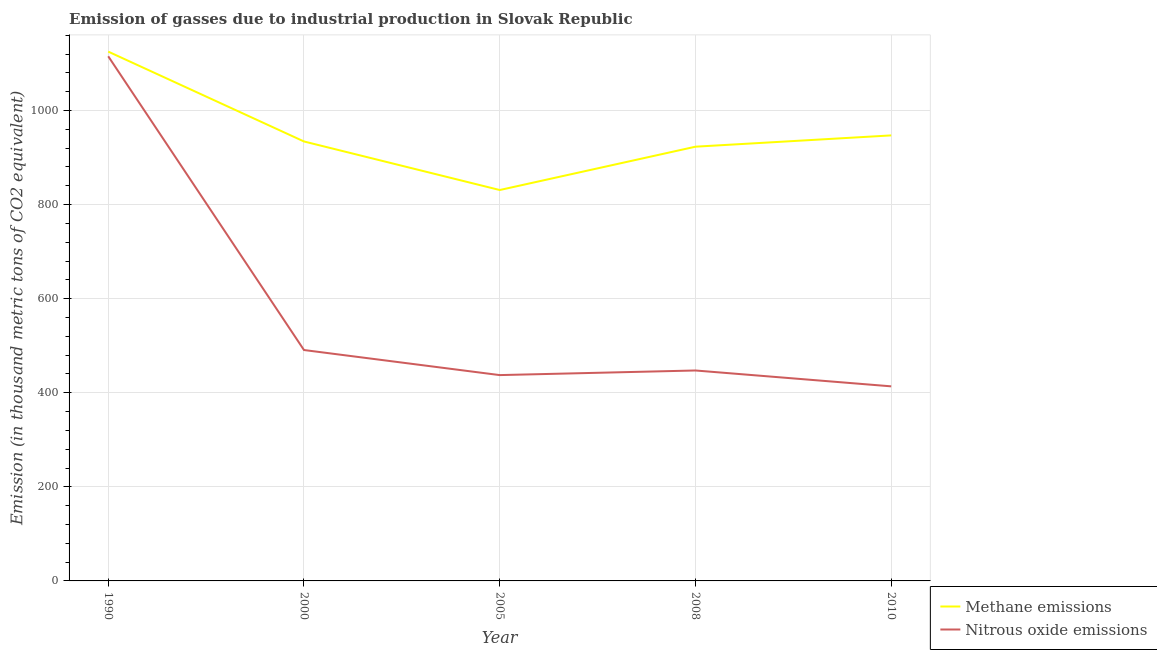What is the amount of nitrous oxide emissions in 2000?
Give a very brief answer. 490.8. Across all years, what is the maximum amount of nitrous oxide emissions?
Offer a terse response. 1115.2. Across all years, what is the minimum amount of methane emissions?
Offer a very short reply. 830.9. In which year was the amount of methane emissions minimum?
Provide a short and direct response. 2005. What is the total amount of methane emissions in the graph?
Your response must be concise. 4760.1. What is the difference between the amount of methane emissions in 2000 and that in 2010?
Offer a very short reply. -12.9. What is the difference between the amount of methane emissions in 2008 and the amount of nitrous oxide emissions in 2000?
Ensure brevity in your answer.  432.2. What is the average amount of methane emissions per year?
Offer a terse response. 952.02. In the year 1990, what is the difference between the amount of methane emissions and amount of nitrous oxide emissions?
Give a very brief answer. 9.9. What is the ratio of the amount of nitrous oxide emissions in 2000 to that in 2008?
Keep it short and to the point. 1.1. Is the amount of methane emissions in 1990 less than that in 2005?
Offer a very short reply. No. What is the difference between the highest and the second highest amount of nitrous oxide emissions?
Keep it short and to the point. 624.4. What is the difference between the highest and the lowest amount of nitrous oxide emissions?
Give a very brief answer. 701.6. In how many years, is the amount of methane emissions greater than the average amount of methane emissions taken over all years?
Offer a terse response. 1. Is the sum of the amount of nitrous oxide emissions in 2008 and 2010 greater than the maximum amount of methane emissions across all years?
Make the answer very short. No. What is the difference between two consecutive major ticks on the Y-axis?
Your answer should be very brief. 200. Are the values on the major ticks of Y-axis written in scientific E-notation?
Make the answer very short. No. Does the graph contain any zero values?
Your response must be concise. No. Does the graph contain grids?
Offer a very short reply. Yes. How many legend labels are there?
Offer a terse response. 2. What is the title of the graph?
Give a very brief answer. Emission of gasses due to industrial production in Slovak Republic. What is the label or title of the Y-axis?
Provide a short and direct response. Emission (in thousand metric tons of CO2 equivalent). What is the Emission (in thousand metric tons of CO2 equivalent) in Methane emissions in 1990?
Make the answer very short. 1125.1. What is the Emission (in thousand metric tons of CO2 equivalent) in Nitrous oxide emissions in 1990?
Your answer should be very brief. 1115.2. What is the Emission (in thousand metric tons of CO2 equivalent) in Methane emissions in 2000?
Ensure brevity in your answer.  934.1. What is the Emission (in thousand metric tons of CO2 equivalent) in Nitrous oxide emissions in 2000?
Give a very brief answer. 490.8. What is the Emission (in thousand metric tons of CO2 equivalent) of Methane emissions in 2005?
Give a very brief answer. 830.9. What is the Emission (in thousand metric tons of CO2 equivalent) in Nitrous oxide emissions in 2005?
Ensure brevity in your answer.  437.5. What is the Emission (in thousand metric tons of CO2 equivalent) of Methane emissions in 2008?
Ensure brevity in your answer.  923. What is the Emission (in thousand metric tons of CO2 equivalent) of Nitrous oxide emissions in 2008?
Give a very brief answer. 447.3. What is the Emission (in thousand metric tons of CO2 equivalent) of Methane emissions in 2010?
Offer a terse response. 947. What is the Emission (in thousand metric tons of CO2 equivalent) in Nitrous oxide emissions in 2010?
Give a very brief answer. 413.6. Across all years, what is the maximum Emission (in thousand metric tons of CO2 equivalent) in Methane emissions?
Provide a succinct answer. 1125.1. Across all years, what is the maximum Emission (in thousand metric tons of CO2 equivalent) in Nitrous oxide emissions?
Offer a very short reply. 1115.2. Across all years, what is the minimum Emission (in thousand metric tons of CO2 equivalent) in Methane emissions?
Provide a short and direct response. 830.9. Across all years, what is the minimum Emission (in thousand metric tons of CO2 equivalent) in Nitrous oxide emissions?
Give a very brief answer. 413.6. What is the total Emission (in thousand metric tons of CO2 equivalent) of Methane emissions in the graph?
Your answer should be very brief. 4760.1. What is the total Emission (in thousand metric tons of CO2 equivalent) of Nitrous oxide emissions in the graph?
Offer a terse response. 2904.4. What is the difference between the Emission (in thousand metric tons of CO2 equivalent) in Methane emissions in 1990 and that in 2000?
Ensure brevity in your answer.  191. What is the difference between the Emission (in thousand metric tons of CO2 equivalent) of Nitrous oxide emissions in 1990 and that in 2000?
Ensure brevity in your answer.  624.4. What is the difference between the Emission (in thousand metric tons of CO2 equivalent) in Methane emissions in 1990 and that in 2005?
Ensure brevity in your answer.  294.2. What is the difference between the Emission (in thousand metric tons of CO2 equivalent) of Nitrous oxide emissions in 1990 and that in 2005?
Give a very brief answer. 677.7. What is the difference between the Emission (in thousand metric tons of CO2 equivalent) in Methane emissions in 1990 and that in 2008?
Provide a short and direct response. 202.1. What is the difference between the Emission (in thousand metric tons of CO2 equivalent) in Nitrous oxide emissions in 1990 and that in 2008?
Make the answer very short. 667.9. What is the difference between the Emission (in thousand metric tons of CO2 equivalent) in Methane emissions in 1990 and that in 2010?
Give a very brief answer. 178.1. What is the difference between the Emission (in thousand metric tons of CO2 equivalent) of Nitrous oxide emissions in 1990 and that in 2010?
Give a very brief answer. 701.6. What is the difference between the Emission (in thousand metric tons of CO2 equivalent) of Methane emissions in 2000 and that in 2005?
Give a very brief answer. 103.2. What is the difference between the Emission (in thousand metric tons of CO2 equivalent) of Nitrous oxide emissions in 2000 and that in 2005?
Keep it short and to the point. 53.3. What is the difference between the Emission (in thousand metric tons of CO2 equivalent) in Nitrous oxide emissions in 2000 and that in 2008?
Offer a very short reply. 43.5. What is the difference between the Emission (in thousand metric tons of CO2 equivalent) of Methane emissions in 2000 and that in 2010?
Your answer should be compact. -12.9. What is the difference between the Emission (in thousand metric tons of CO2 equivalent) in Nitrous oxide emissions in 2000 and that in 2010?
Your response must be concise. 77.2. What is the difference between the Emission (in thousand metric tons of CO2 equivalent) in Methane emissions in 2005 and that in 2008?
Offer a very short reply. -92.1. What is the difference between the Emission (in thousand metric tons of CO2 equivalent) of Nitrous oxide emissions in 2005 and that in 2008?
Your answer should be very brief. -9.8. What is the difference between the Emission (in thousand metric tons of CO2 equivalent) of Methane emissions in 2005 and that in 2010?
Make the answer very short. -116.1. What is the difference between the Emission (in thousand metric tons of CO2 equivalent) of Nitrous oxide emissions in 2005 and that in 2010?
Ensure brevity in your answer.  23.9. What is the difference between the Emission (in thousand metric tons of CO2 equivalent) in Nitrous oxide emissions in 2008 and that in 2010?
Offer a very short reply. 33.7. What is the difference between the Emission (in thousand metric tons of CO2 equivalent) of Methane emissions in 1990 and the Emission (in thousand metric tons of CO2 equivalent) of Nitrous oxide emissions in 2000?
Provide a succinct answer. 634.3. What is the difference between the Emission (in thousand metric tons of CO2 equivalent) of Methane emissions in 1990 and the Emission (in thousand metric tons of CO2 equivalent) of Nitrous oxide emissions in 2005?
Your answer should be compact. 687.6. What is the difference between the Emission (in thousand metric tons of CO2 equivalent) of Methane emissions in 1990 and the Emission (in thousand metric tons of CO2 equivalent) of Nitrous oxide emissions in 2008?
Your answer should be compact. 677.8. What is the difference between the Emission (in thousand metric tons of CO2 equivalent) in Methane emissions in 1990 and the Emission (in thousand metric tons of CO2 equivalent) in Nitrous oxide emissions in 2010?
Provide a succinct answer. 711.5. What is the difference between the Emission (in thousand metric tons of CO2 equivalent) of Methane emissions in 2000 and the Emission (in thousand metric tons of CO2 equivalent) of Nitrous oxide emissions in 2005?
Provide a short and direct response. 496.6. What is the difference between the Emission (in thousand metric tons of CO2 equivalent) in Methane emissions in 2000 and the Emission (in thousand metric tons of CO2 equivalent) in Nitrous oxide emissions in 2008?
Offer a terse response. 486.8. What is the difference between the Emission (in thousand metric tons of CO2 equivalent) in Methane emissions in 2000 and the Emission (in thousand metric tons of CO2 equivalent) in Nitrous oxide emissions in 2010?
Offer a very short reply. 520.5. What is the difference between the Emission (in thousand metric tons of CO2 equivalent) of Methane emissions in 2005 and the Emission (in thousand metric tons of CO2 equivalent) of Nitrous oxide emissions in 2008?
Provide a succinct answer. 383.6. What is the difference between the Emission (in thousand metric tons of CO2 equivalent) of Methane emissions in 2005 and the Emission (in thousand metric tons of CO2 equivalent) of Nitrous oxide emissions in 2010?
Your answer should be compact. 417.3. What is the difference between the Emission (in thousand metric tons of CO2 equivalent) of Methane emissions in 2008 and the Emission (in thousand metric tons of CO2 equivalent) of Nitrous oxide emissions in 2010?
Your response must be concise. 509.4. What is the average Emission (in thousand metric tons of CO2 equivalent) of Methane emissions per year?
Make the answer very short. 952.02. What is the average Emission (in thousand metric tons of CO2 equivalent) of Nitrous oxide emissions per year?
Give a very brief answer. 580.88. In the year 2000, what is the difference between the Emission (in thousand metric tons of CO2 equivalent) of Methane emissions and Emission (in thousand metric tons of CO2 equivalent) of Nitrous oxide emissions?
Your answer should be compact. 443.3. In the year 2005, what is the difference between the Emission (in thousand metric tons of CO2 equivalent) in Methane emissions and Emission (in thousand metric tons of CO2 equivalent) in Nitrous oxide emissions?
Provide a short and direct response. 393.4. In the year 2008, what is the difference between the Emission (in thousand metric tons of CO2 equivalent) of Methane emissions and Emission (in thousand metric tons of CO2 equivalent) of Nitrous oxide emissions?
Your answer should be very brief. 475.7. In the year 2010, what is the difference between the Emission (in thousand metric tons of CO2 equivalent) of Methane emissions and Emission (in thousand metric tons of CO2 equivalent) of Nitrous oxide emissions?
Keep it short and to the point. 533.4. What is the ratio of the Emission (in thousand metric tons of CO2 equivalent) in Methane emissions in 1990 to that in 2000?
Your response must be concise. 1.2. What is the ratio of the Emission (in thousand metric tons of CO2 equivalent) of Nitrous oxide emissions in 1990 to that in 2000?
Offer a very short reply. 2.27. What is the ratio of the Emission (in thousand metric tons of CO2 equivalent) in Methane emissions in 1990 to that in 2005?
Provide a succinct answer. 1.35. What is the ratio of the Emission (in thousand metric tons of CO2 equivalent) in Nitrous oxide emissions in 1990 to that in 2005?
Provide a succinct answer. 2.55. What is the ratio of the Emission (in thousand metric tons of CO2 equivalent) in Methane emissions in 1990 to that in 2008?
Offer a very short reply. 1.22. What is the ratio of the Emission (in thousand metric tons of CO2 equivalent) in Nitrous oxide emissions in 1990 to that in 2008?
Provide a short and direct response. 2.49. What is the ratio of the Emission (in thousand metric tons of CO2 equivalent) of Methane emissions in 1990 to that in 2010?
Provide a succinct answer. 1.19. What is the ratio of the Emission (in thousand metric tons of CO2 equivalent) of Nitrous oxide emissions in 1990 to that in 2010?
Offer a terse response. 2.7. What is the ratio of the Emission (in thousand metric tons of CO2 equivalent) in Methane emissions in 2000 to that in 2005?
Offer a terse response. 1.12. What is the ratio of the Emission (in thousand metric tons of CO2 equivalent) of Nitrous oxide emissions in 2000 to that in 2005?
Your response must be concise. 1.12. What is the ratio of the Emission (in thousand metric tons of CO2 equivalent) of Methane emissions in 2000 to that in 2008?
Offer a very short reply. 1.01. What is the ratio of the Emission (in thousand metric tons of CO2 equivalent) in Nitrous oxide emissions in 2000 to that in 2008?
Provide a short and direct response. 1.1. What is the ratio of the Emission (in thousand metric tons of CO2 equivalent) of Methane emissions in 2000 to that in 2010?
Make the answer very short. 0.99. What is the ratio of the Emission (in thousand metric tons of CO2 equivalent) of Nitrous oxide emissions in 2000 to that in 2010?
Offer a terse response. 1.19. What is the ratio of the Emission (in thousand metric tons of CO2 equivalent) of Methane emissions in 2005 to that in 2008?
Offer a terse response. 0.9. What is the ratio of the Emission (in thousand metric tons of CO2 equivalent) in Nitrous oxide emissions in 2005 to that in 2008?
Offer a terse response. 0.98. What is the ratio of the Emission (in thousand metric tons of CO2 equivalent) in Methane emissions in 2005 to that in 2010?
Provide a short and direct response. 0.88. What is the ratio of the Emission (in thousand metric tons of CO2 equivalent) of Nitrous oxide emissions in 2005 to that in 2010?
Ensure brevity in your answer.  1.06. What is the ratio of the Emission (in thousand metric tons of CO2 equivalent) in Methane emissions in 2008 to that in 2010?
Offer a very short reply. 0.97. What is the ratio of the Emission (in thousand metric tons of CO2 equivalent) of Nitrous oxide emissions in 2008 to that in 2010?
Make the answer very short. 1.08. What is the difference between the highest and the second highest Emission (in thousand metric tons of CO2 equivalent) in Methane emissions?
Keep it short and to the point. 178.1. What is the difference between the highest and the second highest Emission (in thousand metric tons of CO2 equivalent) in Nitrous oxide emissions?
Offer a terse response. 624.4. What is the difference between the highest and the lowest Emission (in thousand metric tons of CO2 equivalent) of Methane emissions?
Make the answer very short. 294.2. What is the difference between the highest and the lowest Emission (in thousand metric tons of CO2 equivalent) of Nitrous oxide emissions?
Offer a very short reply. 701.6. 